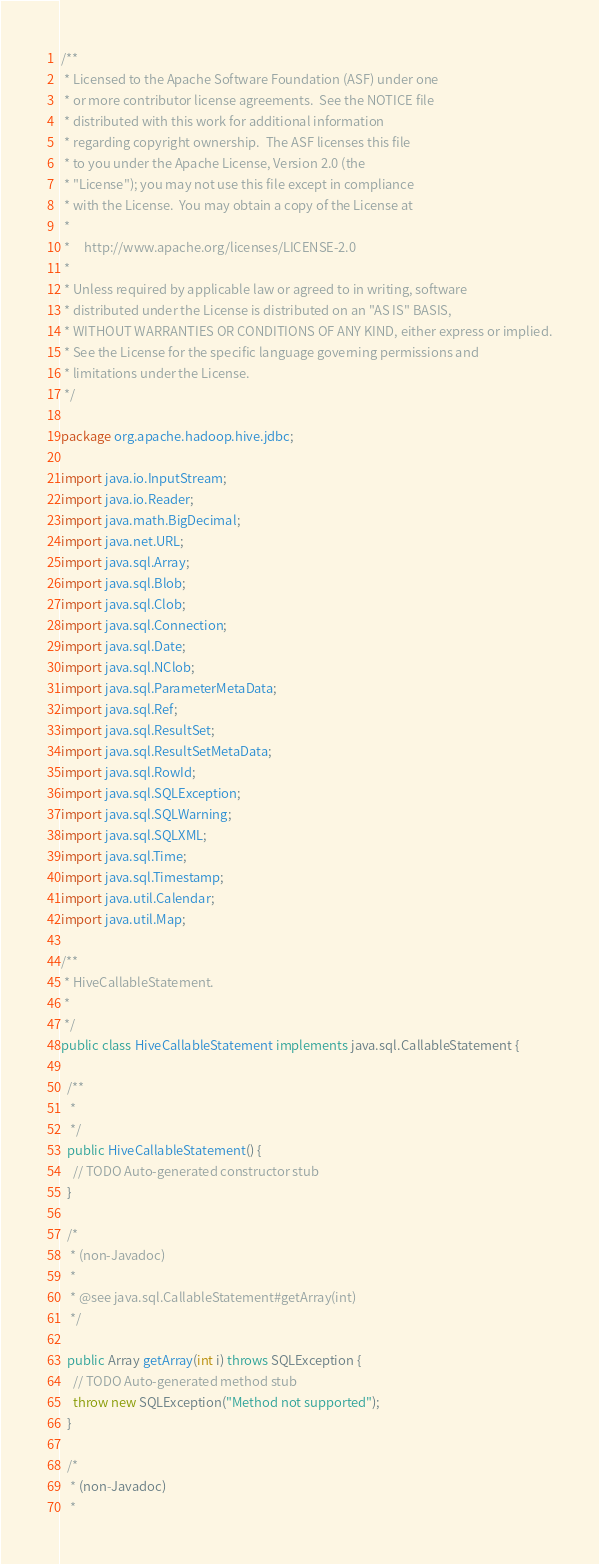Convert code to text. <code><loc_0><loc_0><loc_500><loc_500><_Java_>/**
 * Licensed to the Apache Software Foundation (ASF) under one
 * or more contributor license agreements.  See the NOTICE file
 * distributed with this work for additional information
 * regarding copyright ownership.  The ASF licenses this file
 * to you under the Apache License, Version 2.0 (the
 * "License"); you may not use this file except in compliance
 * with the License.  You may obtain a copy of the License at
 *
 *     http://www.apache.org/licenses/LICENSE-2.0
 *
 * Unless required by applicable law or agreed to in writing, software
 * distributed under the License is distributed on an "AS IS" BASIS,
 * WITHOUT WARRANTIES OR CONDITIONS OF ANY KIND, either express or implied.
 * See the License for the specific language governing permissions and
 * limitations under the License.
 */

package org.apache.hadoop.hive.jdbc;

import java.io.InputStream;
import java.io.Reader;
import java.math.BigDecimal;
import java.net.URL;
import java.sql.Array;
import java.sql.Blob;
import java.sql.Clob;
import java.sql.Connection;
import java.sql.Date;
import java.sql.NClob;
import java.sql.ParameterMetaData;
import java.sql.Ref;
import java.sql.ResultSet;
import java.sql.ResultSetMetaData;
import java.sql.RowId;
import java.sql.SQLException;
import java.sql.SQLWarning;
import java.sql.SQLXML;
import java.sql.Time;
import java.sql.Timestamp;
import java.util.Calendar;
import java.util.Map;

/**
 * HiveCallableStatement.
 *
 */
public class HiveCallableStatement implements java.sql.CallableStatement {

  /**
   *
   */
  public HiveCallableStatement() {
    // TODO Auto-generated constructor stub
  }

  /*
   * (non-Javadoc)
   * 
   * @see java.sql.CallableStatement#getArray(int)
   */

  public Array getArray(int i) throws SQLException {
    // TODO Auto-generated method stub
    throw new SQLException("Method not supported");
  }

  /*
   * (non-Javadoc)
   * </code> 